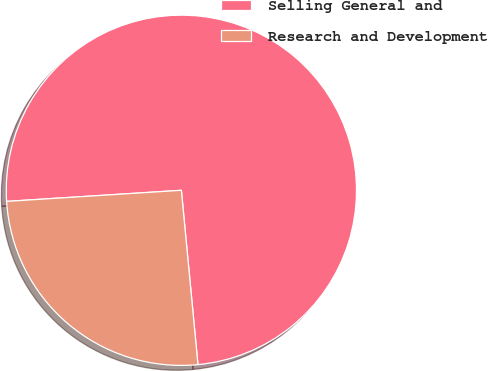Convert chart. <chart><loc_0><loc_0><loc_500><loc_500><pie_chart><fcel>Selling General and<fcel>Research and Development<nl><fcel>74.5%<fcel>25.5%<nl></chart> 